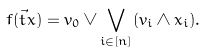<formula> <loc_0><loc_0><loc_500><loc_500>f ( \vec { t } { x } ) = v _ { 0 } \vee \bigvee _ { i \in [ n ] } ( v _ { i } \wedge x _ { i } ) .</formula> 